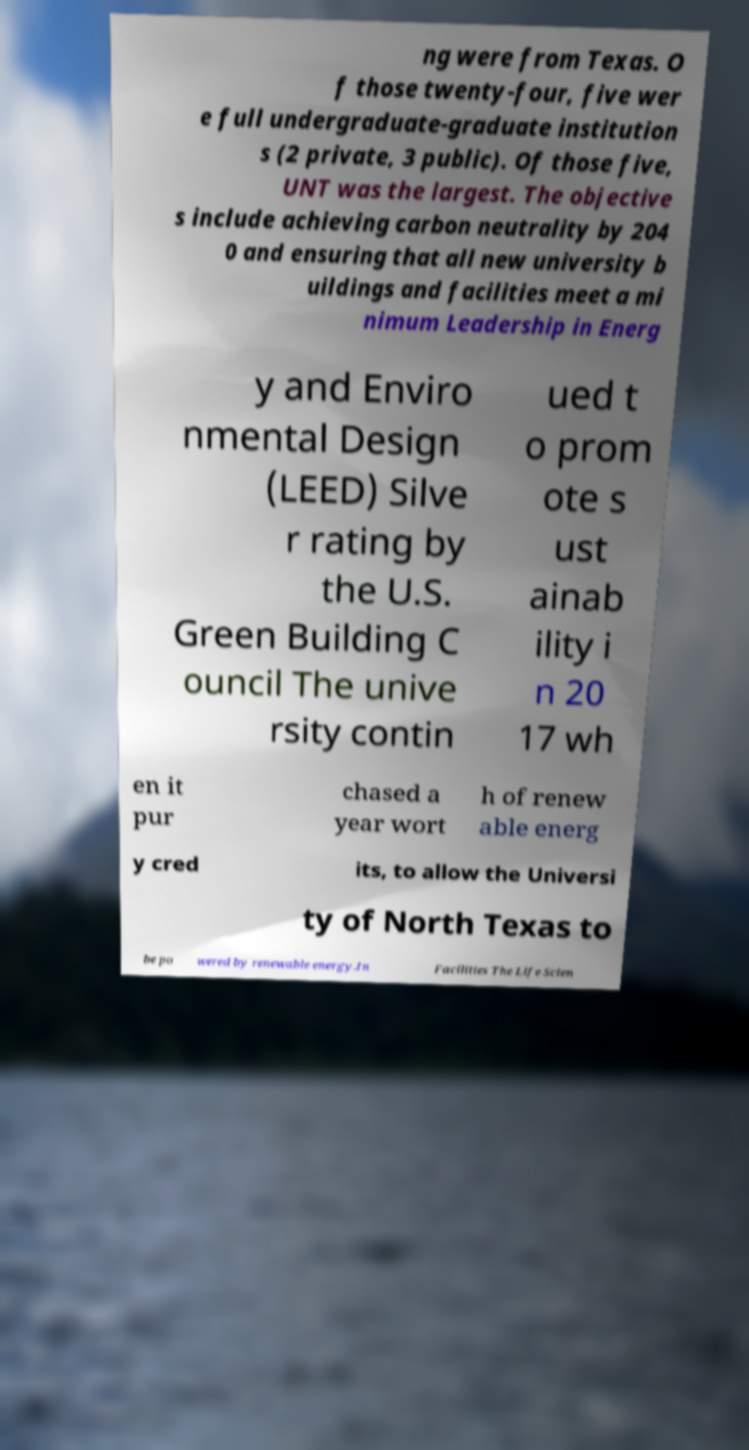Can you read and provide the text displayed in the image?This photo seems to have some interesting text. Can you extract and type it out for me? ng were from Texas. O f those twenty-four, five wer e full undergraduate-graduate institution s (2 private, 3 public). Of those five, UNT was the largest. The objective s include achieving carbon neutrality by 204 0 and ensuring that all new university b uildings and facilities meet a mi nimum Leadership in Energ y and Enviro nmental Design (LEED) Silve r rating by the U.S. Green Building C ouncil The unive rsity contin ued t o prom ote s ust ainab ility i n 20 17 wh en it pur chased a year wort h of renew able energ y cred its, to allow the Universi ty of North Texas to be po wered by renewable energy.In Facilities The Life Scien 